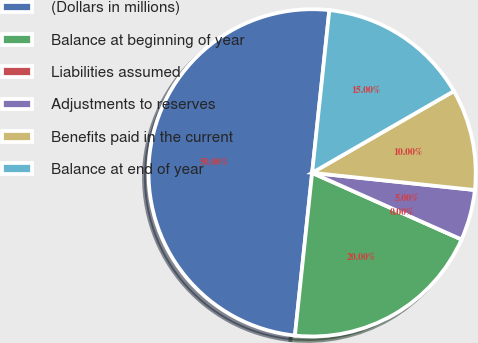Convert chart. <chart><loc_0><loc_0><loc_500><loc_500><pie_chart><fcel>(Dollars in millions)<fcel>Balance at beginning of year<fcel>Liabilities assumed<fcel>Adjustments to reserves<fcel>Benefits paid in the current<fcel>Balance at end of year<nl><fcel>50.0%<fcel>20.0%<fcel>0.0%<fcel>5.0%<fcel>10.0%<fcel>15.0%<nl></chart> 